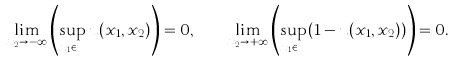Convert formula to latex. <formula><loc_0><loc_0><loc_500><loc_500>\lim _ { x _ { 2 } \to - \infty } \left ( \sup _ { x _ { 1 } \in \mathbb { R } } u ( x _ { 1 } , x _ { 2 } ) \right ) = 0 , \quad \lim _ { x _ { 2 } \to + \infty } \left ( \sup _ { x _ { 1 } \in \mathbb { R } } ( 1 - u ( x _ { 1 } , x _ { 2 } ) ) \right ) = 0 .</formula> 